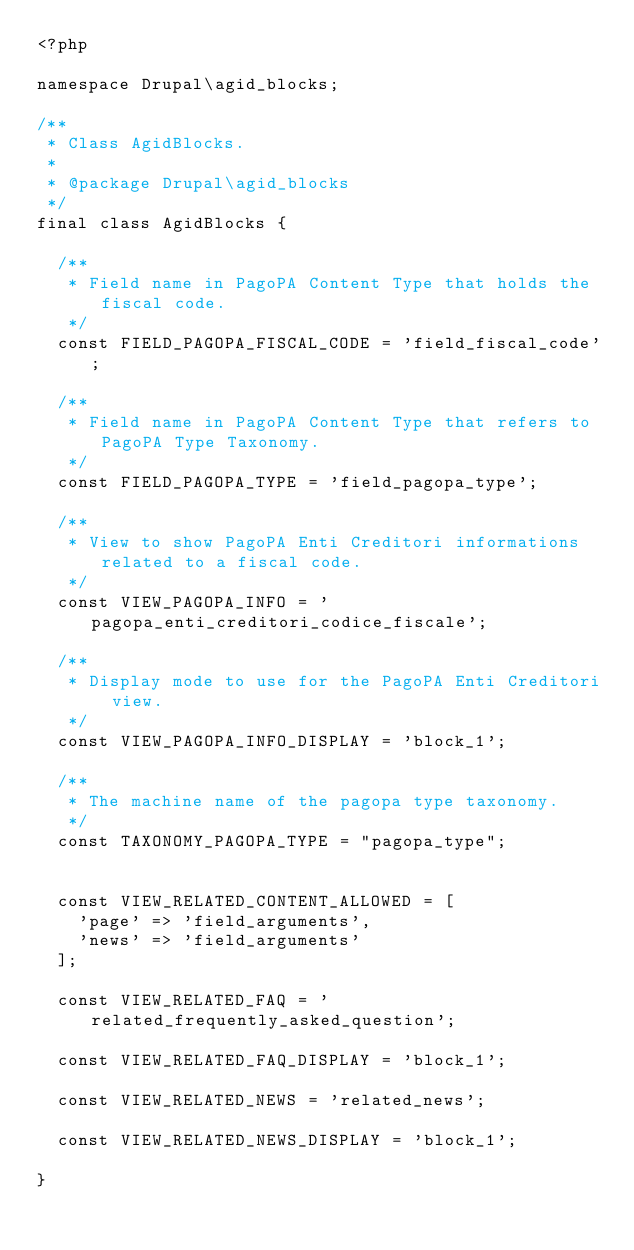Convert code to text. <code><loc_0><loc_0><loc_500><loc_500><_PHP_><?php

namespace Drupal\agid_blocks;

/**
 * Class AgidBlocks.
 *
 * @package Drupal\agid_blocks
 */
final class AgidBlocks {

  /**
   * Field name in PagoPA Content Type that holds the fiscal code.
   */
  const FIELD_PAGOPA_FISCAL_CODE = 'field_fiscal_code';

  /**
   * Field name in PagoPA Content Type that refers to PagoPA Type Taxonomy.
   */
  const FIELD_PAGOPA_TYPE = 'field_pagopa_type';

  /**
   * View to show PagoPA Enti Creditori informations related to a fiscal code.
   */
  const VIEW_PAGOPA_INFO = 'pagopa_enti_creditori_codice_fiscale';

  /**
   * Display mode to use for the PagoPA Enti Creditori view.
   */
  const VIEW_PAGOPA_INFO_DISPLAY = 'block_1';

  /**
   * The machine name of the pagopa type taxonomy.
   */
  const TAXONOMY_PAGOPA_TYPE = "pagopa_type";


  const VIEW_RELATED_CONTENT_ALLOWED = [
    'page' => 'field_arguments',
    'news' => 'field_arguments'
  ];

  const VIEW_RELATED_FAQ = 'related_frequently_asked_question';

  const VIEW_RELATED_FAQ_DISPLAY = 'block_1';

  const VIEW_RELATED_NEWS = 'related_news';

  const VIEW_RELATED_NEWS_DISPLAY = 'block_1';

}
</code> 